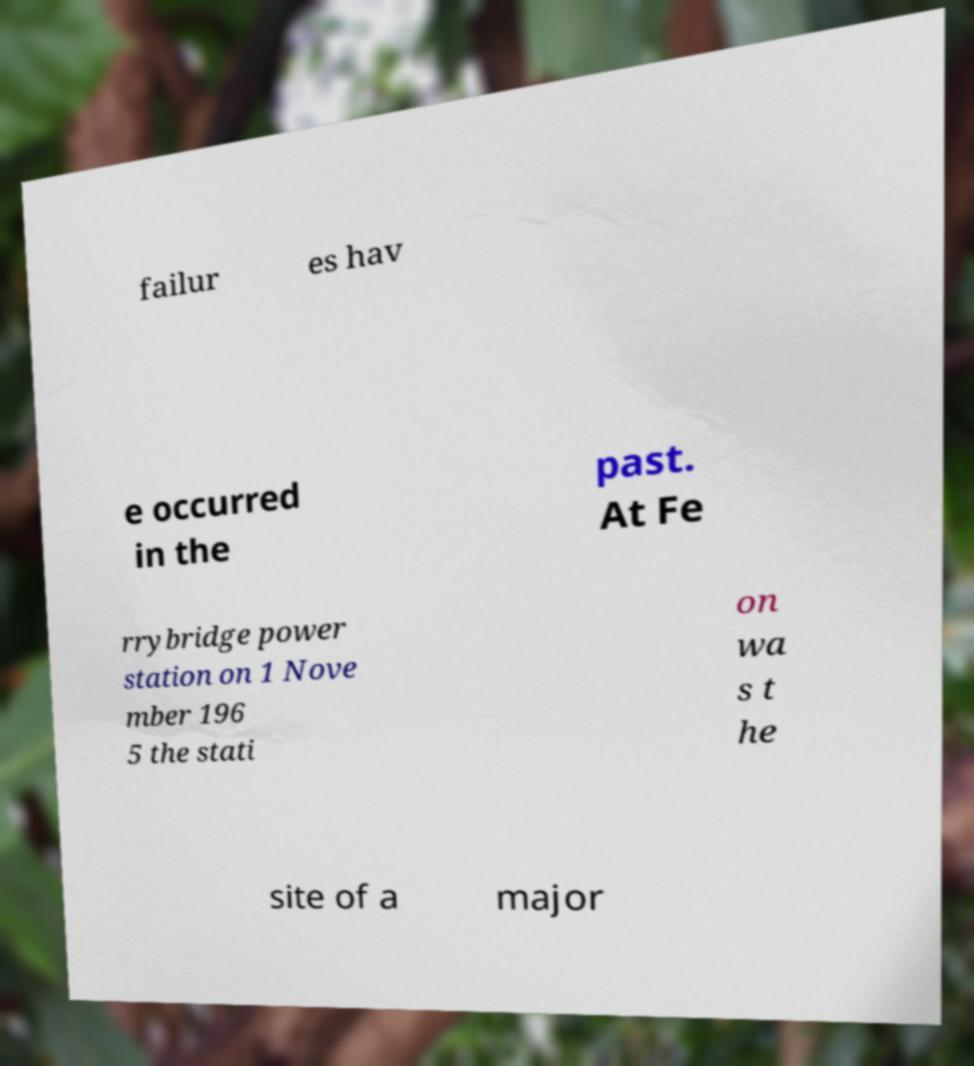Can you accurately transcribe the text from the provided image for me? failur es hav e occurred in the past. At Fe rrybridge power station on 1 Nove mber 196 5 the stati on wa s t he site of a major 